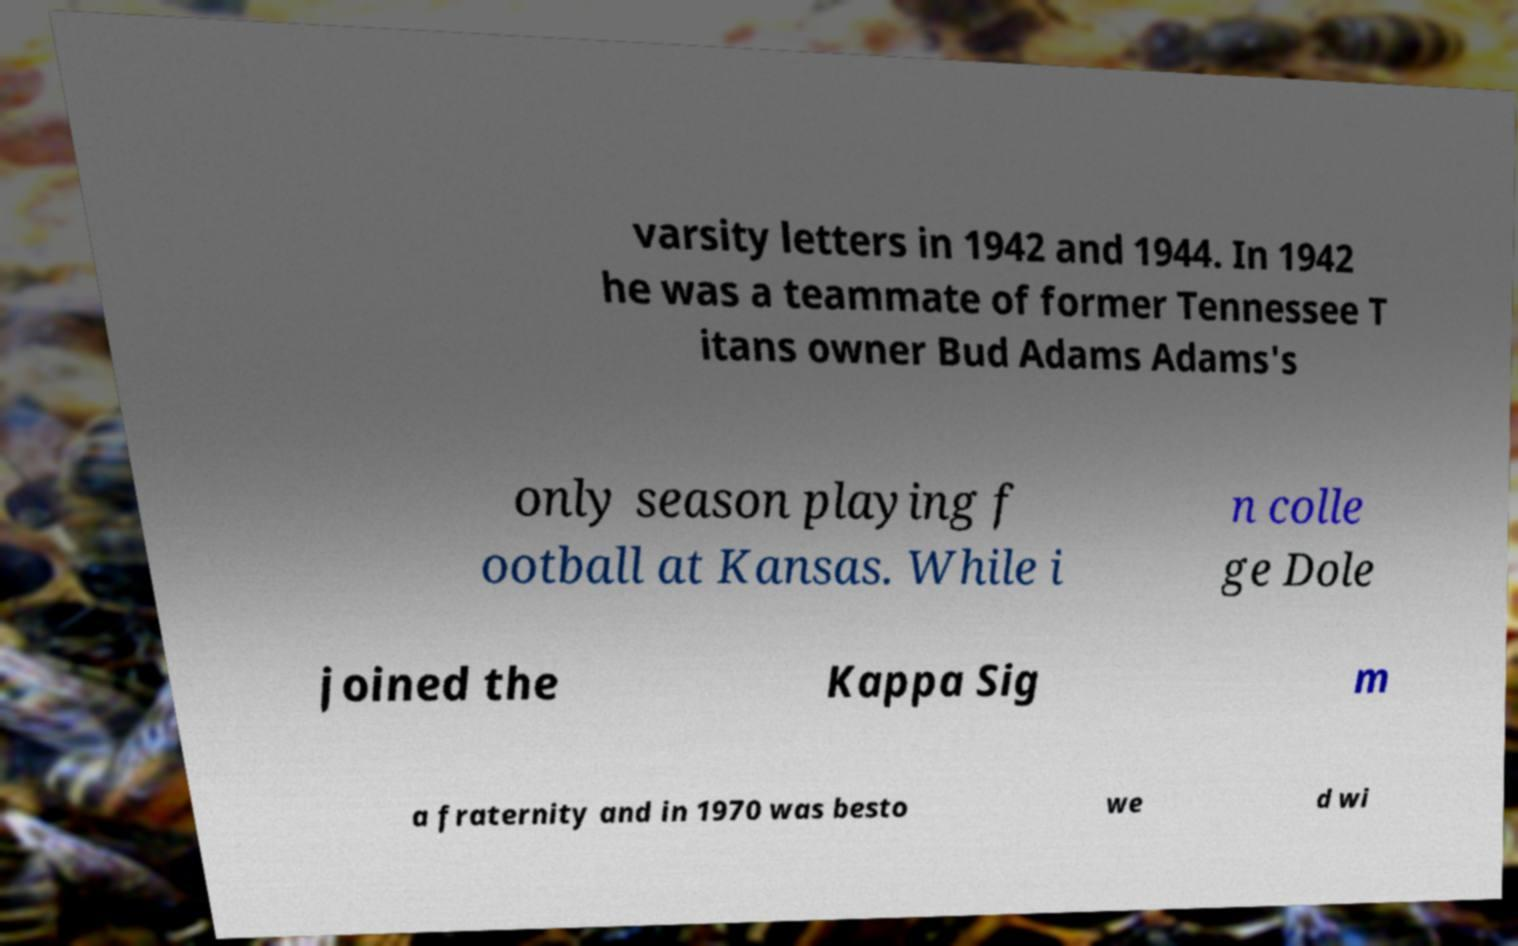What messages or text are displayed in this image? I need them in a readable, typed format. varsity letters in 1942 and 1944. In 1942 he was a teammate of former Tennessee T itans owner Bud Adams Adams's only season playing f ootball at Kansas. While i n colle ge Dole joined the Kappa Sig m a fraternity and in 1970 was besto we d wi 